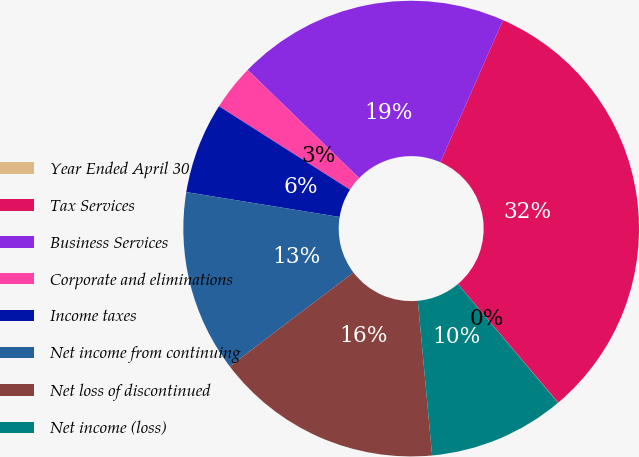Convert chart to OTSL. <chart><loc_0><loc_0><loc_500><loc_500><pie_chart><fcel>Year Ended April 30<fcel>Tax Services<fcel>Business Services<fcel>Corporate and eliminations<fcel>Income taxes<fcel>Net income from continuing<fcel>Net loss of discontinued<fcel>Net income (loss)<nl><fcel>0.02%<fcel>32.22%<fcel>19.34%<fcel>3.24%<fcel>6.46%<fcel>12.9%<fcel>16.12%<fcel>9.68%<nl></chart> 